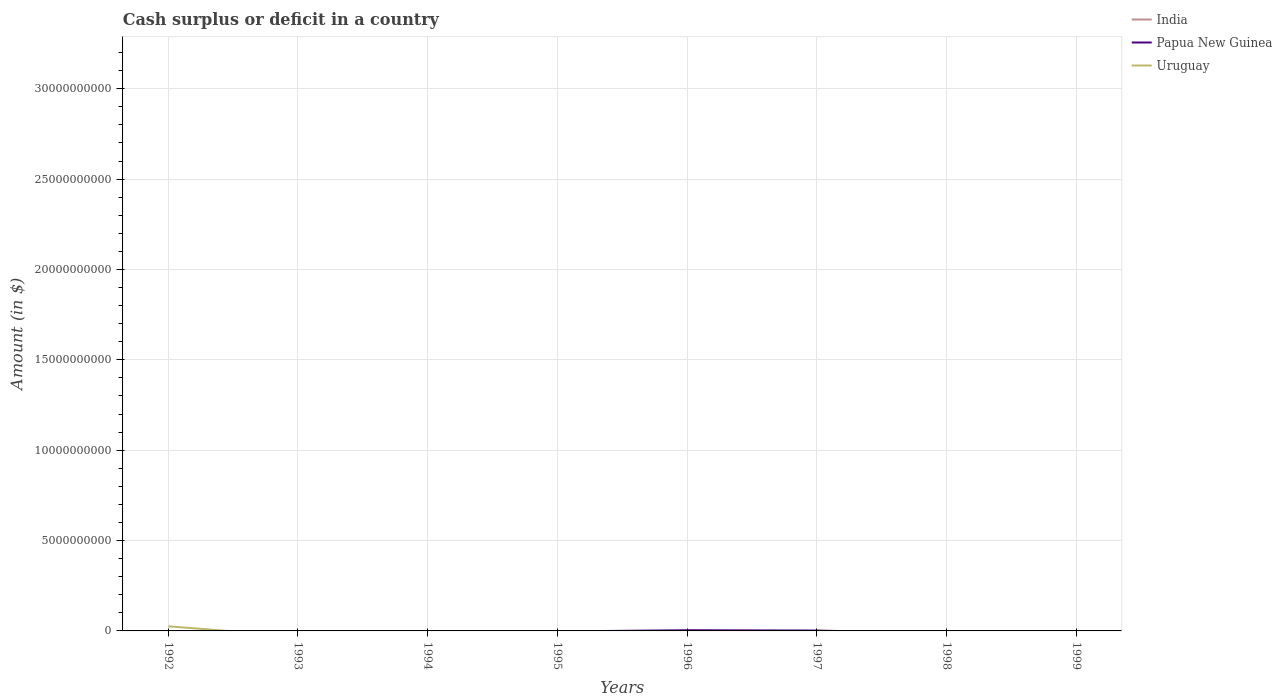How many different coloured lines are there?
Provide a succinct answer. 2. What is the difference between the highest and the second highest amount of cash surplus or deficit in Papua New Guinea?
Your answer should be compact. 3.88e+07. What is the difference between the highest and the lowest amount of cash surplus or deficit in India?
Your answer should be very brief. 0. Is the amount of cash surplus or deficit in Uruguay strictly greater than the amount of cash surplus or deficit in India over the years?
Offer a terse response. No. How many years are there in the graph?
Ensure brevity in your answer.  8. What is the difference between two consecutive major ticks on the Y-axis?
Your answer should be compact. 5.00e+09. Are the values on the major ticks of Y-axis written in scientific E-notation?
Provide a short and direct response. No. How many legend labels are there?
Provide a short and direct response. 3. What is the title of the graph?
Make the answer very short. Cash surplus or deficit in a country. Does "Bermuda" appear as one of the legend labels in the graph?
Provide a short and direct response. No. What is the label or title of the Y-axis?
Provide a short and direct response. Amount (in $). What is the Amount (in $) of Uruguay in 1992?
Your response must be concise. 2.56e+08. What is the Amount (in $) in India in 1993?
Offer a terse response. 0. What is the Amount (in $) of Uruguay in 1993?
Your response must be concise. 0. What is the Amount (in $) in Uruguay in 1994?
Give a very brief answer. 0. What is the Amount (in $) in India in 1995?
Offer a very short reply. 0. What is the Amount (in $) in India in 1996?
Provide a succinct answer. 0. What is the Amount (in $) of Papua New Guinea in 1996?
Your answer should be compact. 3.88e+07. What is the Amount (in $) of Uruguay in 1996?
Provide a succinct answer. 0. What is the Amount (in $) in Papua New Guinea in 1997?
Offer a terse response. 2.03e+07. What is the Amount (in $) in India in 1998?
Your response must be concise. 0. What is the Amount (in $) in India in 1999?
Give a very brief answer. 0. What is the Amount (in $) in Uruguay in 1999?
Your answer should be very brief. 0. Across all years, what is the maximum Amount (in $) of Papua New Guinea?
Ensure brevity in your answer.  3.88e+07. Across all years, what is the maximum Amount (in $) in Uruguay?
Ensure brevity in your answer.  2.56e+08. Across all years, what is the minimum Amount (in $) in Uruguay?
Your answer should be very brief. 0. What is the total Amount (in $) in India in the graph?
Your answer should be compact. 0. What is the total Amount (in $) of Papua New Guinea in the graph?
Offer a terse response. 5.92e+07. What is the total Amount (in $) in Uruguay in the graph?
Offer a very short reply. 2.56e+08. What is the difference between the Amount (in $) of Papua New Guinea in 1996 and that in 1997?
Offer a very short reply. 1.85e+07. What is the average Amount (in $) of Papua New Guinea per year?
Provide a succinct answer. 7.39e+06. What is the average Amount (in $) in Uruguay per year?
Make the answer very short. 3.20e+07. What is the ratio of the Amount (in $) in Papua New Guinea in 1996 to that in 1997?
Give a very brief answer. 1.91. What is the difference between the highest and the lowest Amount (in $) of Papua New Guinea?
Provide a short and direct response. 3.88e+07. What is the difference between the highest and the lowest Amount (in $) of Uruguay?
Keep it short and to the point. 2.56e+08. 